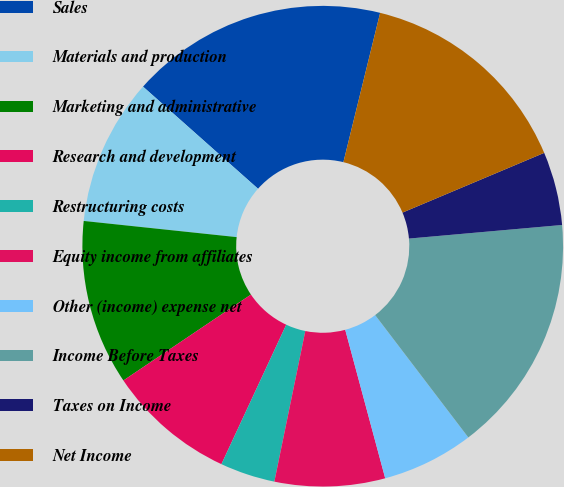Convert chart. <chart><loc_0><loc_0><loc_500><loc_500><pie_chart><fcel>Sales<fcel>Materials and production<fcel>Marketing and administrative<fcel>Research and development<fcel>Restructuring costs<fcel>Equity income from affiliates<fcel>Other (income) expense net<fcel>Income Before Taxes<fcel>Taxes on Income<fcel>Net Income<nl><fcel>17.28%<fcel>9.88%<fcel>11.11%<fcel>8.64%<fcel>3.7%<fcel>7.41%<fcel>6.17%<fcel>16.05%<fcel>4.94%<fcel>14.81%<nl></chart> 